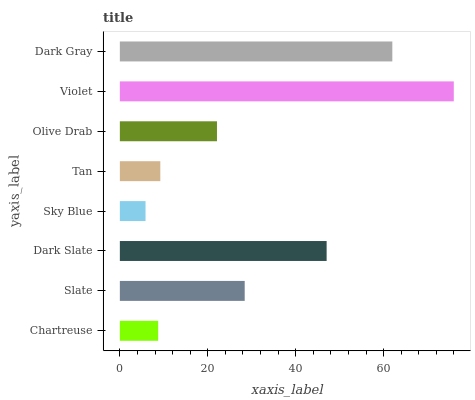Is Sky Blue the minimum?
Answer yes or no. Yes. Is Violet the maximum?
Answer yes or no. Yes. Is Slate the minimum?
Answer yes or no. No. Is Slate the maximum?
Answer yes or no. No. Is Slate greater than Chartreuse?
Answer yes or no. Yes. Is Chartreuse less than Slate?
Answer yes or no. Yes. Is Chartreuse greater than Slate?
Answer yes or no. No. Is Slate less than Chartreuse?
Answer yes or no. No. Is Slate the high median?
Answer yes or no. Yes. Is Olive Drab the low median?
Answer yes or no. Yes. Is Chartreuse the high median?
Answer yes or no. No. Is Dark Slate the low median?
Answer yes or no. No. 